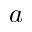Convert formula to latex. <formula><loc_0><loc_0><loc_500><loc_500>a</formula> 